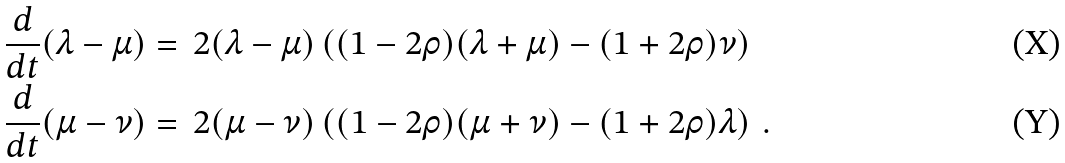Convert formula to latex. <formula><loc_0><loc_0><loc_500><loc_500>\frac { d } { d t } ( \lambda - \mu ) & = \, 2 ( \lambda - \mu ) \left ( ( 1 - 2 \rho ) ( \lambda + \mu ) - ( 1 + 2 \rho ) \nu \right ) \\ \frac { d } { d t } ( \mu - \nu ) & = \, 2 ( \mu - \nu ) \left ( ( 1 - 2 \rho ) ( \mu + \nu ) - ( 1 + 2 \rho ) \lambda \right ) \, .</formula> 